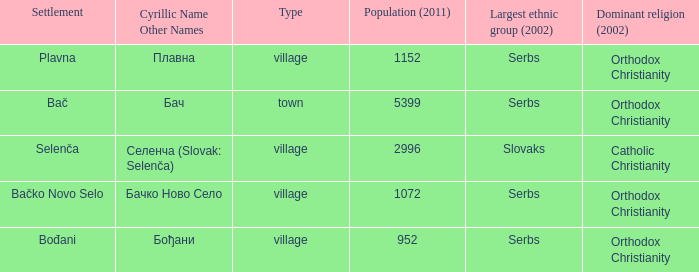Give me the full table as a dictionary. {'header': ['Settlement', 'Cyrillic Name Other Names', 'Type', 'Population (2011)', 'Largest ethnic group (2002)', 'Dominant religion (2002)'], 'rows': [['Plavna', 'Плавна', 'village', '1152', 'Serbs', 'Orthodox Christianity'], ['Bač', 'Бач', 'town', '5399', 'Serbs', 'Orthodox Christianity'], ['Selenča', 'Селенча (Slovak: Selenča)', 'village', '2996', 'Slovaks', 'Catholic Christianity'], ['Bačko Novo Selo', 'Бачко Ново Село', 'village', '1072', 'Serbs', 'Orthodox Christianity'], ['Bođani', 'Бођани', 'village', '952', 'Serbs', 'Orthodox Christianity']]} How to you write  плавна with the latin alphabet? Plavna. 